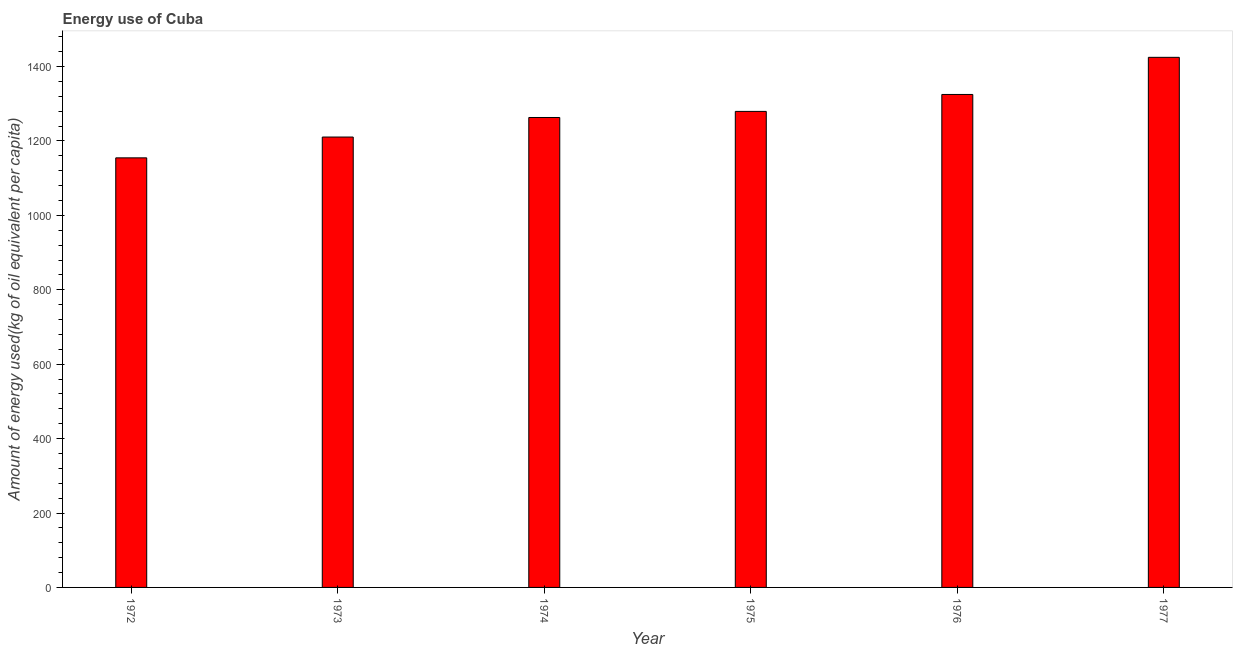Does the graph contain any zero values?
Make the answer very short. No. Does the graph contain grids?
Your answer should be compact. No. What is the title of the graph?
Provide a short and direct response. Energy use of Cuba. What is the label or title of the X-axis?
Make the answer very short. Year. What is the label or title of the Y-axis?
Provide a short and direct response. Amount of energy used(kg of oil equivalent per capita). What is the amount of energy used in 1975?
Make the answer very short. 1279.42. Across all years, what is the maximum amount of energy used?
Offer a very short reply. 1424.74. Across all years, what is the minimum amount of energy used?
Ensure brevity in your answer.  1154.56. In which year was the amount of energy used maximum?
Offer a terse response. 1977. What is the sum of the amount of energy used?
Make the answer very short. 7657.21. What is the difference between the amount of energy used in 1975 and 1976?
Ensure brevity in your answer.  -45.54. What is the average amount of energy used per year?
Your answer should be compact. 1276.2. What is the median amount of energy used?
Your response must be concise. 1271.23. In how many years, is the amount of energy used greater than 640 kg?
Your answer should be compact. 6. What is the ratio of the amount of energy used in 1972 to that in 1975?
Offer a very short reply. 0.9. Is the difference between the amount of energy used in 1972 and 1974 greater than the difference between any two years?
Make the answer very short. No. What is the difference between the highest and the second highest amount of energy used?
Provide a short and direct response. 99.78. What is the difference between the highest and the lowest amount of energy used?
Give a very brief answer. 270.18. In how many years, is the amount of energy used greater than the average amount of energy used taken over all years?
Provide a succinct answer. 3. How many bars are there?
Offer a very short reply. 6. Are the values on the major ticks of Y-axis written in scientific E-notation?
Your answer should be compact. No. What is the Amount of energy used(kg of oil equivalent per capita) in 1972?
Your answer should be very brief. 1154.56. What is the Amount of energy used(kg of oil equivalent per capita) of 1973?
Provide a succinct answer. 1210.49. What is the Amount of energy used(kg of oil equivalent per capita) of 1974?
Offer a terse response. 1263.05. What is the Amount of energy used(kg of oil equivalent per capita) in 1975?
Ensure brevity in your answer.  1279.42. What is the Amount of energy used(kg of oil equivalent per capita) in 1976?
Make the answer very short. 1324.96. What is the Amount of energy used(kg of oil equivalent per capita) of 1977?
Provide a succinct answer. 1424.74. What is the difference between the Amount of energy used(kg of oil equivalent per capita) in 1972 and 1973?
Provide a succinct answer. -55.94. What is the difference between the Amount of energy used(kg of oil equivalent per capita) in 1972 and 1974?
Offer a very short reply. -108.49. What is the difference between the Amount of energy used(kg of oil equivalent per capita) in 1972 and 1975?
Give a very brief answer. -124.86. What is the difference between the Amount of energy used(kg of oil equivalent per capita) in 1972 and 1976?
Your answer should be very brief. -170.4. What is the difference between the Amount of energy used(kg of oil equivalent per capita) in 1972 and 1977?
Offer a terse response. -270.18. What is the difference between the Amount of energy used(kg of oil equivalent per capita) in 1973 and 1974?
Keep it short and to the point. -52.55. What is the difference between the Amount of energy used(kg of oil equivalent per capita) in 1973 and 1975?
Your answer should be compact. -68.92. What is the difference between the Amount of energy used(kg of oil equivalent per capita) in 1973 and 1976?
Your response must be concise. -114.46. What is the difference between the Amount of energy used(kg of oil equivalent per capita) in 1973 and 1977?
Provide a succinct answer. -214.24. What is the difference between the Amount of energy used(kg of oil equivalent per capita) in 1974 and 1975?
Keep it short and to the point. -16.37. What is the difference between the Amount of energy used(kg of oil equivalent per capita) in 1974 and 1976?
Offer a very short reply. -61.91. What is the difference between the Amount of energy used(kg of oil equivalent per capita) in 1974 and 1977?
Give a very brief answer. -161.69. What is the difference between the Amount of energy used(kg of oil equivalent per capita) in 1975 and 1976?
Your answer should be very brief. -45.54. What is the difference between the Amount of energy used(kg of oil equivalent per capita) in 1975 and 1977?
Ensure brevity in your answer.  -145.32. What is the difference between the Amount of energy used(kg of oil equivalent per capita) in 1976 and 1977?
Offer a terse response. -99.78. What is the ratio of the Amount of energy used(kg of oil equivalent per capita) in 1972 to that in 1973?
Your answer should be very brief. 0.95. What is the ratio of the Amount of energy used(kg of oil equivalent per capita) in 1972 to that in 1974?
Your response must be concise. 0.91. What is the ratio of the Amount of energy used(kg of oil equivalent per capita) in 1972 to that in 1975?
Ensure brevity in your answer.  0.9. What is the ratio of the Amount of energy used(kg of oil equivalent per capita) in 1972 to that in 1976?
Offer a terse response. 0.87. What is the ratio of the Amount of energy used(kg of oil equivalent per capita) in 1972 to that in 1977?
Provide a short and direct response. 0.81. What is the ratio of the Amount of energy used(kg of oil equivalent per capita) in 1973 to that in 1974?
Your answer should be very brief. 0.96. What is the ratio of the Amount of energy used(kg of oil equivalent per capita) in 1973 to that in 1975?
Give a very brief answer. 0.95. What is the ratio of the Amount of energy used(kg of oil equivalent per capita) in 1973 to that in 1976?
Offer a very short reply. 0.91. What is the ratio of the Amount of energy used(kg of oil equivalent per capita) in 1973 to that in 1977?
Ensure brevity in your answer.  0.85. What is the ratio of the Amount of energy used(kg of oil equivalent per capita) in 1974 to that in 1975?
Keep it short and to the point. 0.99. What is the ratio of the Amount of energy used(kg of oil equivalent per capita) in 1974 to that in 1976?
Your answer should be very brief. 0.95. What is the ratio of the Amount of energy used(kg of oil equivalent per capita) in 1974 to that in 1977?
Keep it short and to the point. 0.89. What is the ratio of the Amount of energy used(kg of oil equivalent per capita) in 1975 to that in 1977?
Your answer should be compact. 0.9. 